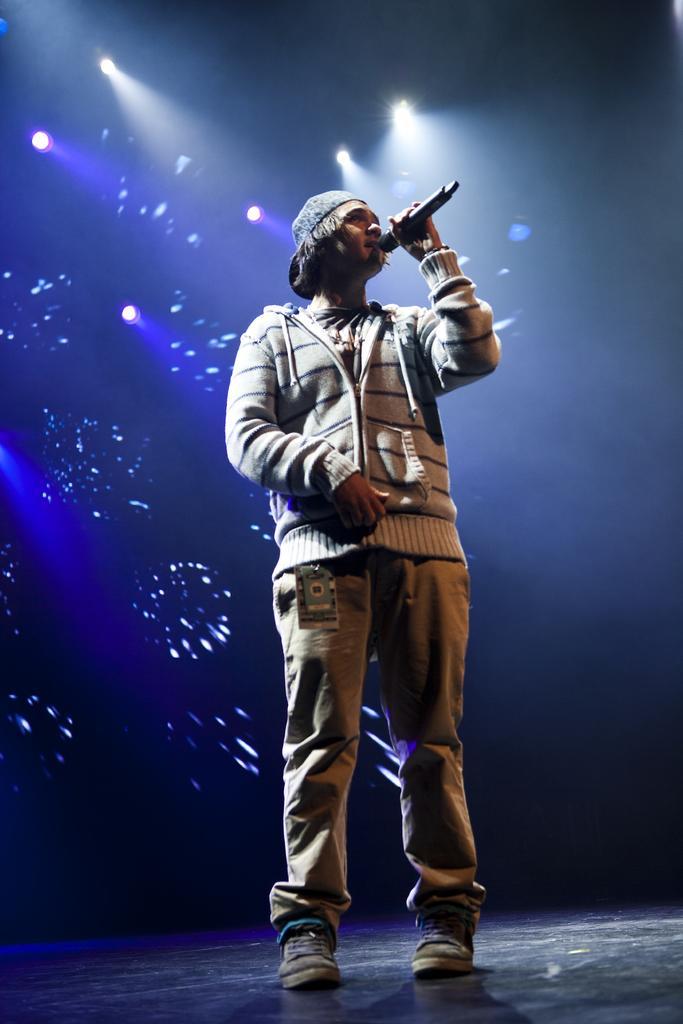Please provide a concise description of this image. This image consists of a man singing in a mic. He is also wearing a tag. At the bottom, there is a floor. In the background, there are lights and a screen. 